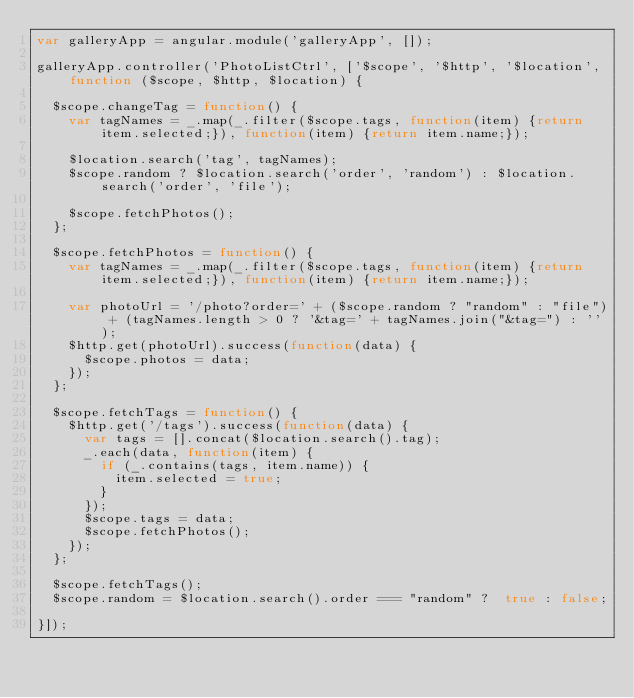<code> <loc_0><loc_0><loc_500><loc_500><_JavaScript_>var galleryApp = angular.module('galleryApp', []);

galleryApp.controller('PhotoListCtrl', ['$scope', '$http', '$location', function ($scope, $http, $location) {
  
  $scope.changeTag = function() {
    var tagNames = _.map(_.filter($scope.tags, function(item) {return item.selected;}), function(item) {return item.name;});

    $location.search('tag', tagNames);
    $scope.random ? $location.search('order', 'random') : $location.search('order', 'file');

    $scope.fetchPhotos();
  };

  $scope.fetchPhotos = function() {
    var tagNames = _.map(_.filter($scope.tags, function(item) {return item.selected;}), function(item) {return item.name;});    

    var photoUrl = '/photo?order=' + ($scope.random ? "random" : "file") + (tagNames.length > 0 ? '&tag=' + tagNames.join("&tag=") : '');
    $http.get(photoUrl).success(function(data) {
      $scope.photos = data;
    });  
  };
  
  $scope.fetchTags = function() {
    $http.get('/tags').success(function(data) {
      var tags = [].concat($location.search().tag);
      _.each(data, function(item) {
        if (_.contains(tags, item.name)) {
          item.selected = true;
        }
      });
      $scope.tags = data;
      $scope.fetchPhotos();
    });  
  };

  $scope.fetchTags();
  $scope.random = $location.search().order === "random" ?  true : false;
  
}]);

</code> 